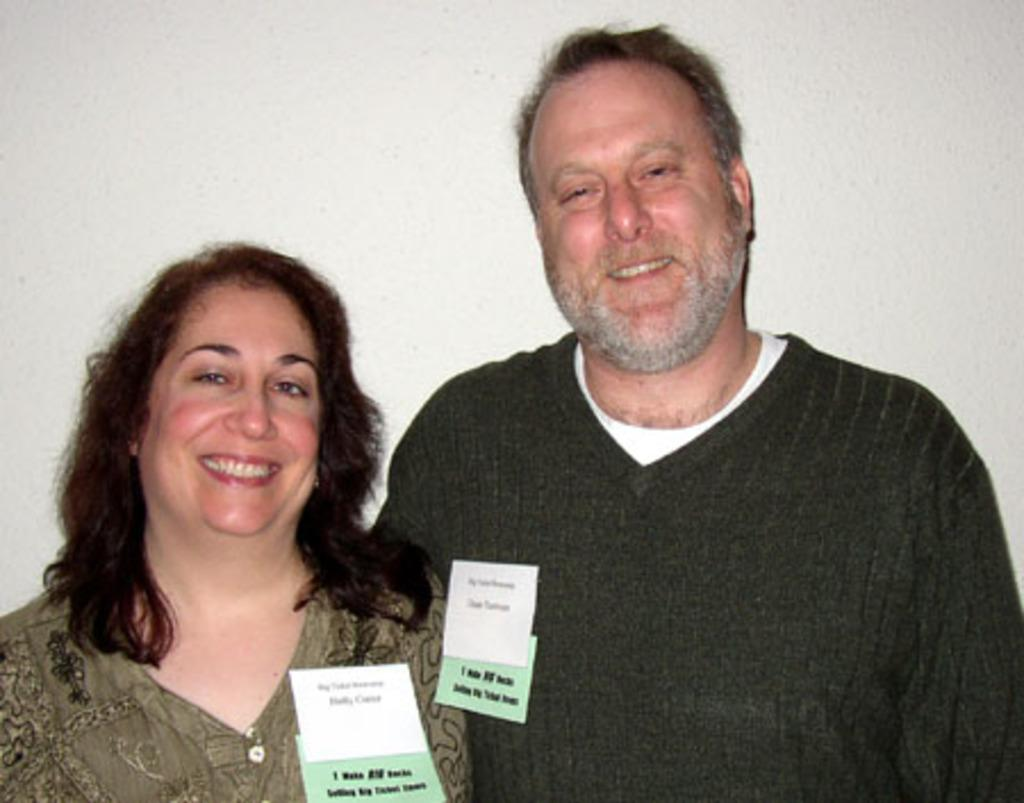How many people are present in the image? There are two people in the image. What can be seen in the background of the image? There is a wall in the background of the image. What type of trouble are the ants causing in the image? There are no ants present in the image, so it is not possible to determine any trouble they might be causing. 